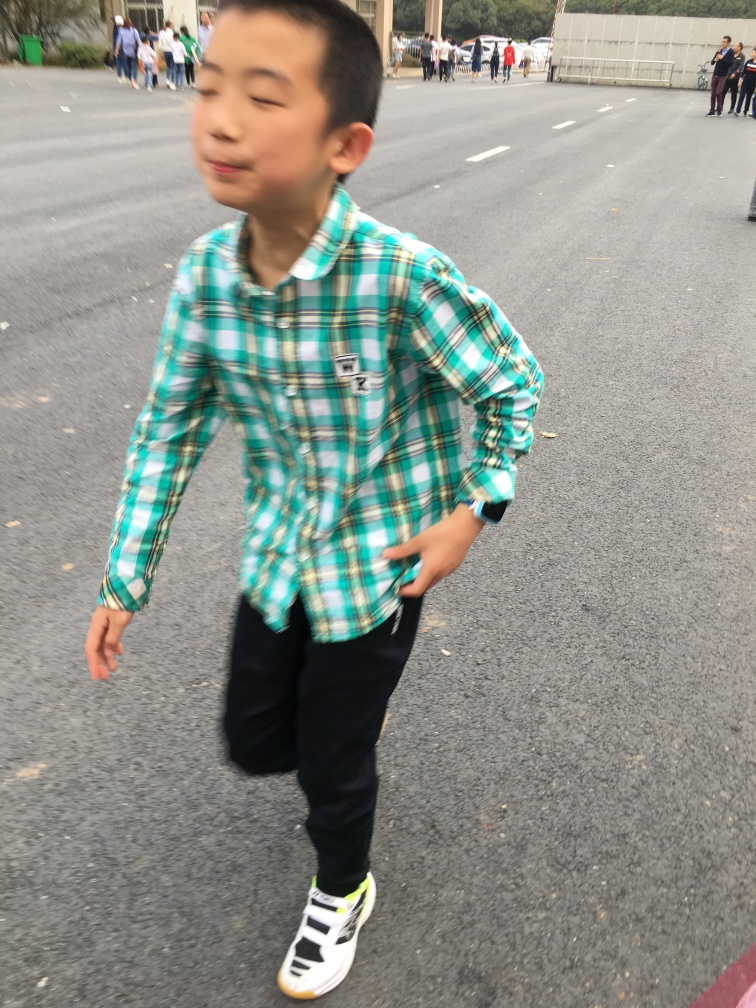What emotions do you think the person in the image is experiencing? The boy in the image appears to be in a state of lightheartedness or play, possibly enjoying a moment of fun outdoors. His slightly open mouth and the blur suggesting movement convey a sense of spontaneity and joyful activity. 